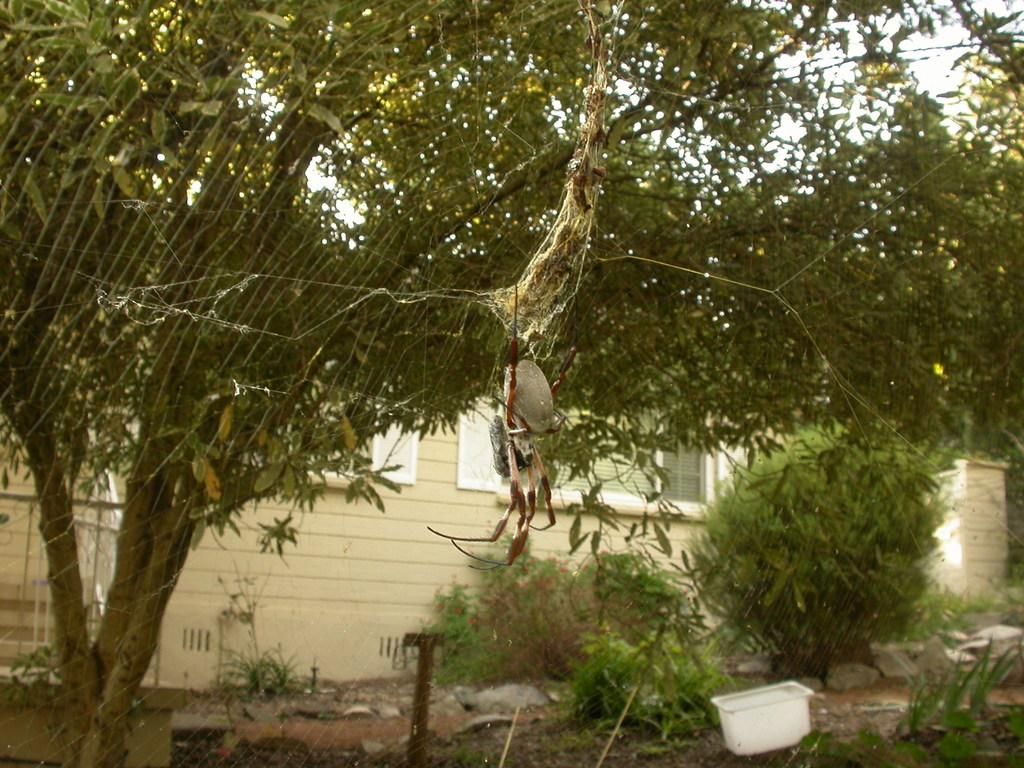What is the main subject of the picture? The main subject of the picture is a web of an insect. What can be seen in the background of the picture? There are many trees and a house in the background of the picture. How many oranges are hanging from the branches of the trees in the image? There is no mention of oranges in the image, so it is not possible to determine how many oranges might be hanging from the trees. 